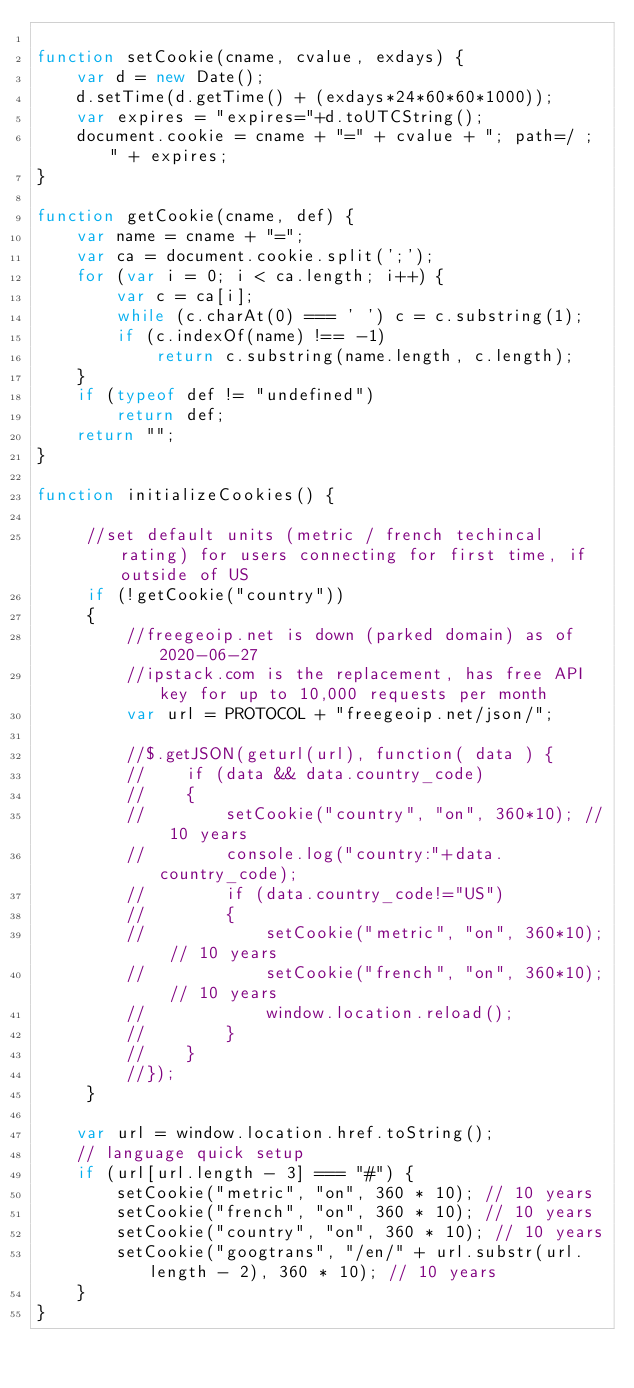Convert code to text. <code><loc_0><loc_0><loc_500><loc_500><_JavaScript_>
function setCookie(cname, cvalue, exdays) {
    var d = new Date();
    d.setTime(d.getTime() + (exdays*24*60*60*1000));
    var expires = "expires="+d.toUTCString();
    document.cookie = cname + "=" + cvalue + "; path=/ ; " + expires;
}

function getCookie(cname, def) {
    var name = cname + "=";
    var ca = document.cookie.split(';');
    for (var i = 0; i < ca.length; i++) {
        var c = ca[i];
        while (c.charAt(0) === ' ') c = c.substring(1);
        if (c.indexOf(name) !== -1)
            return c.substring(name.length, c.length);
    }
    if (typeof def != "undefined")
        return def;
    return "";
}

function initializeCookies() {

     //set default units (metric / french techincal rating) for users connecting for first time, if outside of US
     if (!getCookie("country"))
     {
         //freegeoip.net is down (parked domain) as of 2020-06-27
         //ipstack.com is the replacement, has free API key for up to 10,000 requests per month
         var url = PROTOCOL + "freegeoip.net/json/";

         //$.getJSON(geturl(url), function( data ) {
         //    if (data && data.country_code)
         //    {
         //        setCookie("country", "on", 360*10); // 10 years
         //        console.log("country:"+data.country_code);
         //        if (data.country_code!="US")
         //        {
         //            setCookie("metric", "on", 360*10); // 10 years
         //            setCookie("french", "on", 360*10); // 10 years
         //            window.location.reload();
         //        }
         //    }
         //});
     }

    var url = window.location.href.toString();
    // language quick setup
    if (url[url.length - 3] === "#") {
        setCookie("metric", "on", 360 * 10); // 10 years
        setCookie("french", "on", 360 * 10); // 10 years
        setCookie("country", "on", 360 * 10); // 10 years
        setCookie("googtrans", "/en/" + url.substr(url.length - 2), 360 * 10); // 10 years
    }
}
</code> 